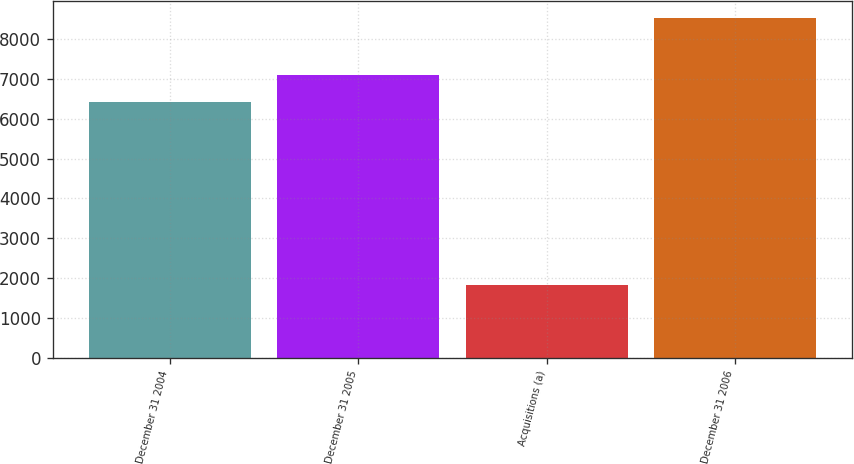Convert chart. <chart><loc_0><loc_0><loc_500><loc_500><bar_chart><fcel>December 31 2004<fcel>December 31 2005<fcel>Acquisitions (a)<fcel>December 31 2006<nl><fcel>6428<fcel>7099<fcel>1831<fcel>8541<nl></chart> 